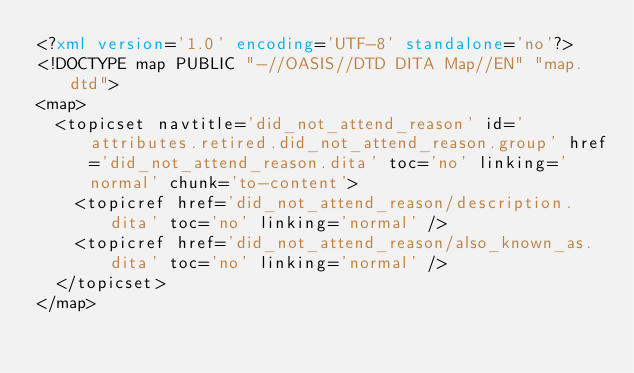Convert code to text. <code><loc_0><loc_0><loc_500><loc_500><_XML_><?xml version='1.0' encoding='UTF-8' standalone='no'?>
<!DOCTYPE map PUBLIC "-//OASIS//DTD DITA Map//EN" "map.dtd">
<map>
  <topicset navtitle='did_not_attend_reason' id='attributes.retired.did_not_attend_reason.group' href='did_not_attend_reason.dita' toc='no' linking='normal' chunk='to-content'>
    <topicref href='did_not_attend_reason/description.dita' toc='no' linking='normal' />
    <topicref href='did_not_attend_reason/also_known_as.dita' toc='no' linking='normal' />
  </topicset>
</map></code> 